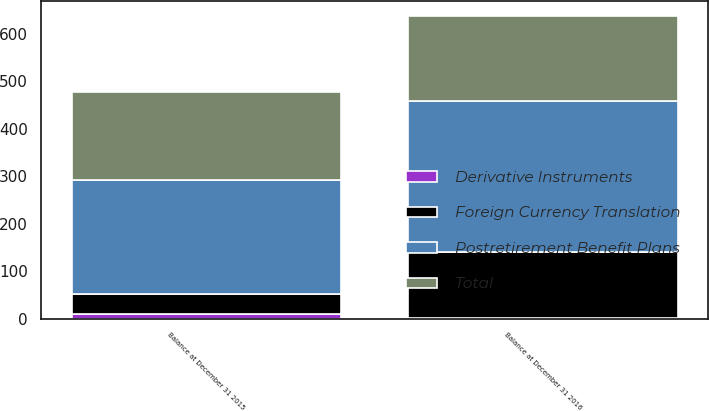<chart> <loc_0><loc_0><loc_500><loc_500><stacked_bar_chart><ecel><fcel>Balance at December 31 2015<fcel>Balance at December 31 2016<nl><fcel>Foreign Currency Translation<fcel>43<fcel>140<nl><fcel>Total<fcel>185<fcel>177<nl><fcel>Derivative Instruments<fcel>10<fcel>1<nl><fcel>Postretirement Benefit Plans<fcel>238<fcel>318<nl></chart> 